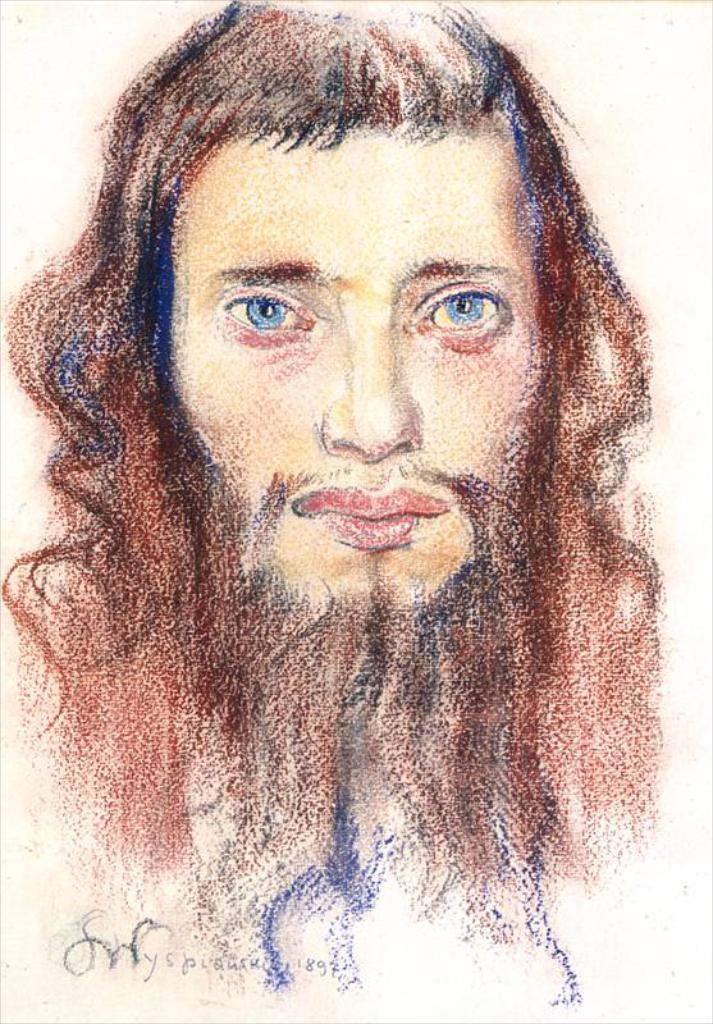What is the main subject of the image? There is an art piece in the image. Can you describe any additional details about the art piece? Unfortunately, the provided facts do not offer any additional details about the art piece. What is written or depicted at the bottom of the image? There is text at the bottom of the image. Where is the playground located in the image? There is no playground present in the image. Can you describe the treatment of the squirrel in the image? There is no squirrel present in the image. 